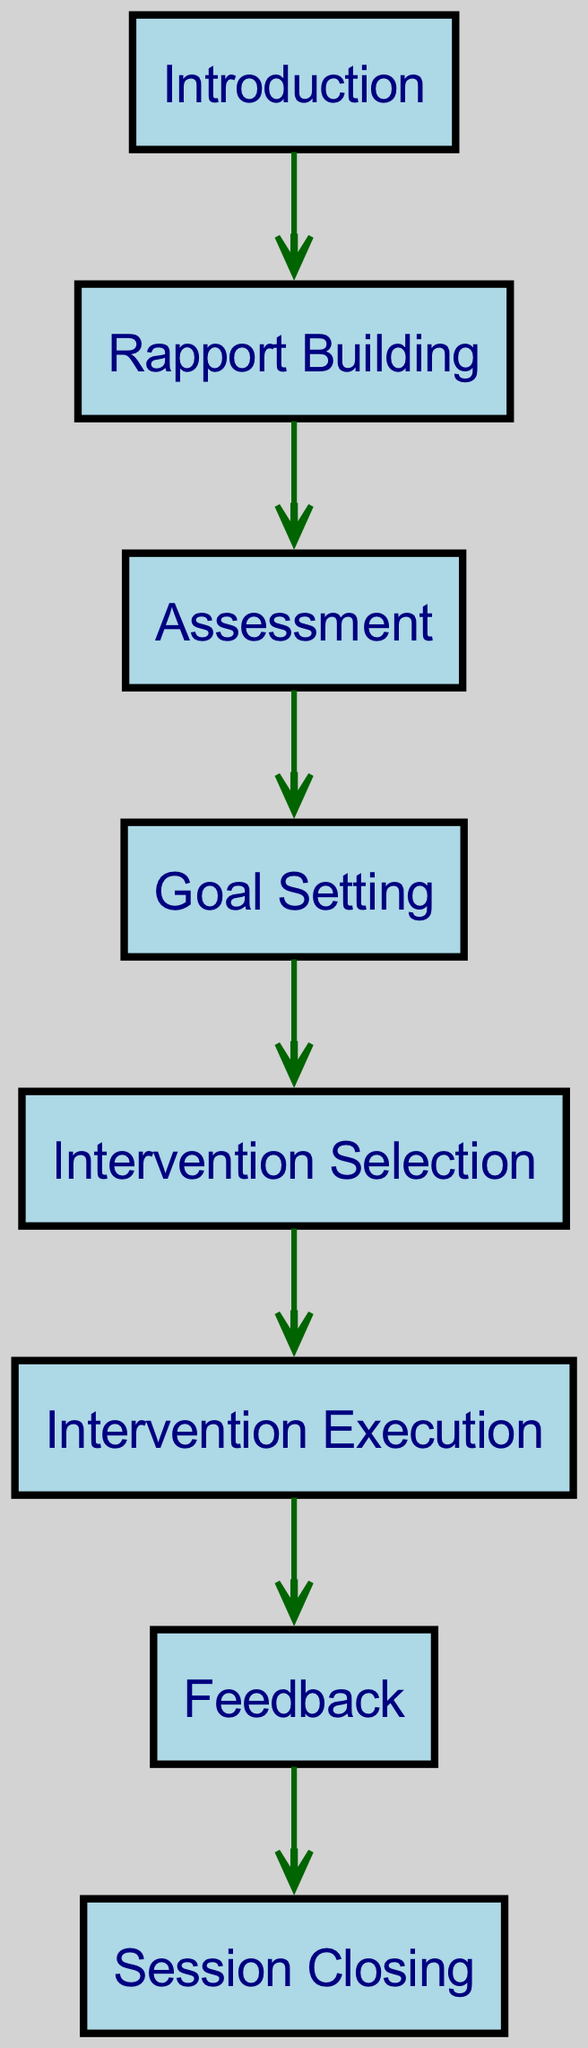What is the first stage of the therapy session structure? The diagram starts with the "Introduction" node, which indicates the first stage in the flowchart.
Answer: Introduction How many nodes are there in the diagram? By counting the number of nodes listed in the data, we find a total of eight distinct stages within the therapy session structure.
Answer: 8 What stage comes immediately after rapport building? The edge leading from "Rapport Building" to "Assessment" shows that "Assessment" is the next stage that follows.
Answer: Assessment What is the final stage of the therapy session structure? The last node in the sequence is "Session Closing," showing it is the final stage as indicated by the arrows leading to it.
Answer: Session Closing Which two stages are directly connected by an edge between goal setting and intervention execution? The flow has an edge going from "Goal Setting" to "Intervention Selection" and then from "Intervention Selection" to "Intervention Execution," indicating a direct connection through these stages.
Answer: Intervention Selection Which node does the feedback stage lead to? The edge flowing out from "Feedback" shows it leads directly to "Session Closing," indicating the next step after feedback.
Answer: Session Closing How many edges are there in the diagram? By counting connections from one node to another, we can determine that there are a total of seven edges in the diagram representing the flow of stages.
Answer: 7 What are the two nodes that are the last before closing the session? The last nodes before "Session Closing" are "Feedback" and the preceding stage leading into it, showing the final stages just before ending.
Answer: Feedback Which node follows the assessment stage? The transition from "Assessment" leads us to "Goal Setting," showing that is the next node in the sequence.
Answer: Goal Setting 